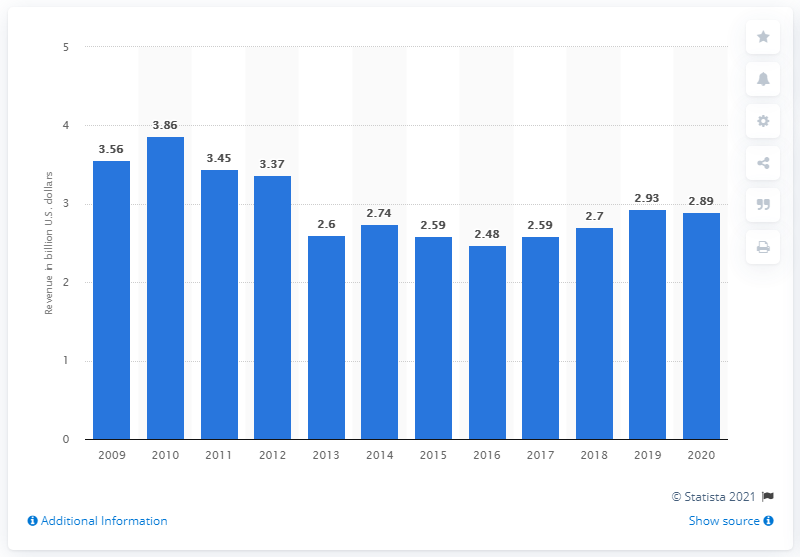Identify some key points in this picture. In 2020, the Graham Holdings Company released its operating revenue. The total revenue of the Graham Holdings Company a year earlier was 2.93 billion dollars. 